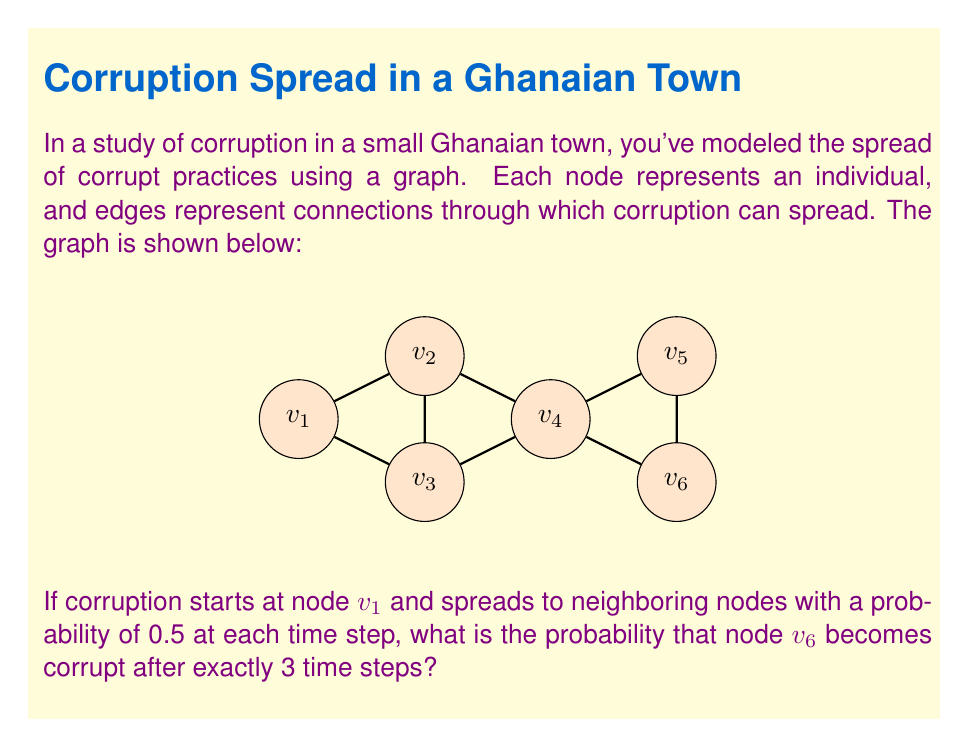Could you help me with this problem? Let's approach this step-by-step:

1) For $v_6$ to be corrupt after exactly 3 steps, the corruption must travel through the path $v_1 \rightarrow v_2 \rightarrow v_3 \rightarrow v_6$ or $v_1 \rightarrow v_2 \rightarrow v_3 \rightarrow v_5 \rightarrow v_6$.

2) The probability of corruption spreading along each edge is 0.5.

3) For the path $v_1 \rightarrow v_2 \rightarrow v_3 \rightarrow v_6$:
   Probability = $0.5 \times 0.5 \times 0.5 = 0.125$

4) For the path $v_1 \rightarrow v_2 \rightarrow v_3 \rightarrow v_5 \rightarrow v_6$:
   This path takes 4 steps, so it doesn't contribute to our probability.

5) Therefore, there's only one valid path for corruption to reach $v_6$ in exactly 3 steps.

6) The probability is thus $0.125$ or $\frac{1}{8}$.
Answer: $\frac{1}{8}$ 